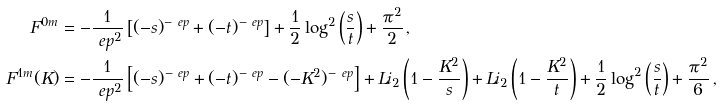<formula> <loc_0><loc_0><loc_500><loc_500>F ^ { 0 m } & = - \frac { 1 } { \ e p ^ { 2 } } \left [ ( - s ) ^ { - \ e p } + ( - t ) ^ { - \ e p } \right ] + \frac { 1 } { 2 } \log ^ { 2 } \left ( \frac { s } { t } \right ) + \frac { \pi ^ { 2 } } { 2 } \, , \\ F ^ { 1 m } ( K ) & = - \frac { 1 } { \ e p ^ { 2 } } \left [ ( - s ) ^ { - \ e p } + ( - t ) ^ { - \ e p } - ( - K ^ { 2 } ) ^ { - \ e p } \right ] + L i _ { 2 } \left ( 1 - \frac { K ^ { 2 } } { s } \right ) + L i _ { 2 } \left ( 1 - \frac { K ^ { 2 } } { t } \right ) + \frac { 1 } { 2 } \log ^ { 2 } \left ( \frac { s } { t } \right ) + \frac { \pi ^ { 2 } } { 6 } \, ,</formula> 